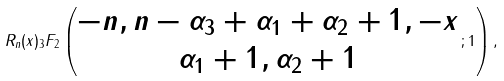Convert formula to latex. <formula><loc_0><loc_0><loc_500><loc_500>R _ { n } ( x ) _ { 3 } F _ { 2 } \left ( \begin{matrix} - n , n - \alpha _ { 3 } + \alpha _ { 1 } + \alpha _ { 2 } + 1 , - x \\ \alpha _ { 1 } + 1 , \alpha _ { 2 } + 1 \end{matrix} \, ; 1 \right ) ,</formula> 